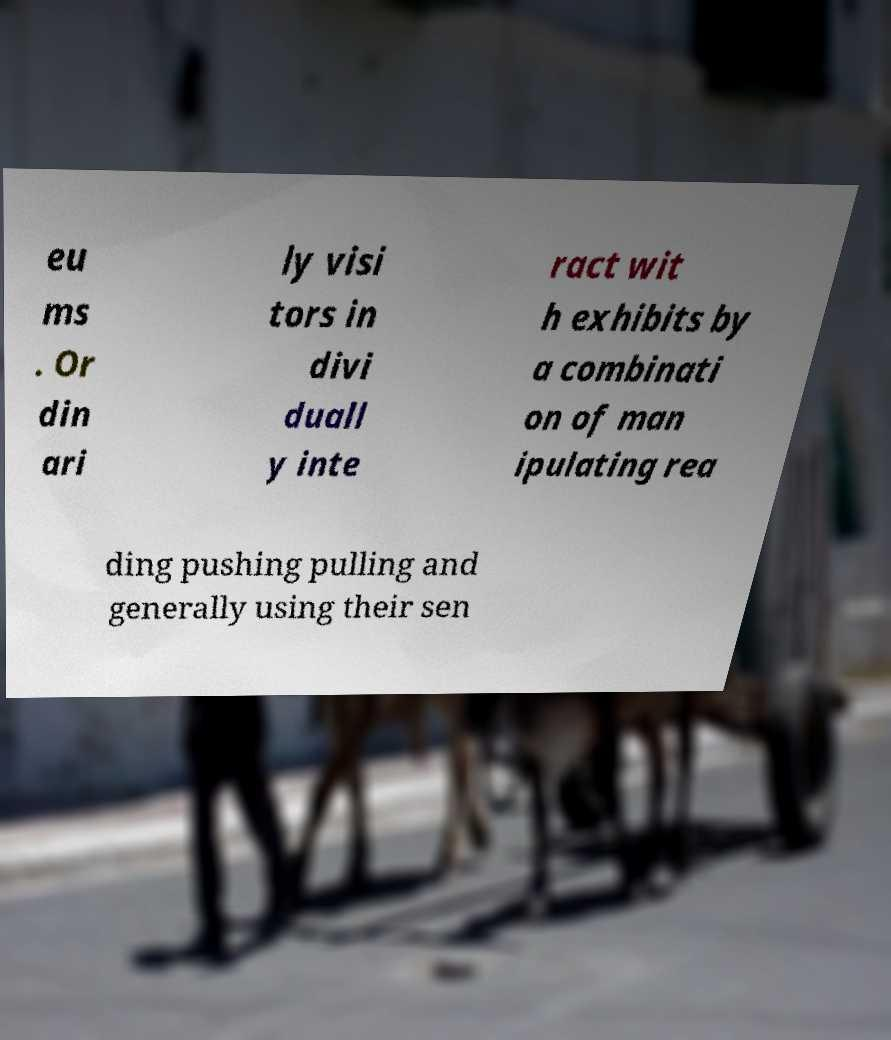Can you accurately transcribe the text from the provided image for me? eu ms . Or din ari ly visi tors in divi duall y inte ract wit h exhibits by a combinati on of man ipulating rea ding pushing pulling and generally using their sen 